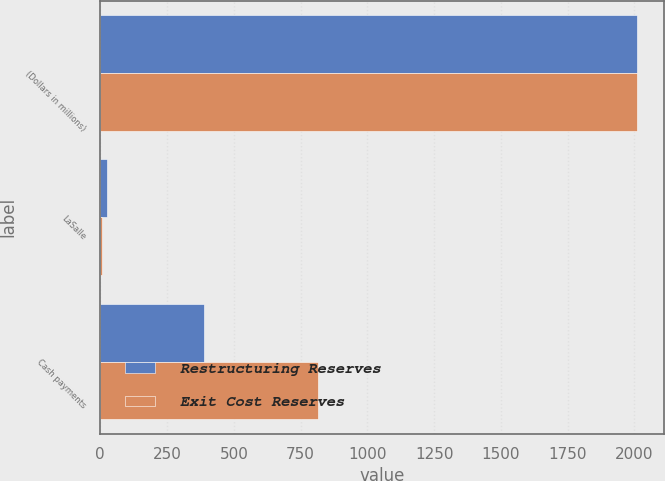Convert chart to OTSL. <chart><loc_0><loc_0><loc_500><loc_500><stacked_bar_chart><ecel><fcel>(Dollars in millions)<fcel>LaSalle<fcel>Cash payments<nl><fcel>Restructuring Reserves<fcel>2009<fcel>24<fcel>387<nl><fcel>Exit Cost Reserves<fcel>2009<fcel>6<fcel>816<nl></chart> 